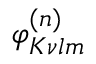<formula> <loc_0><loc_0><loc_500><loc_500>\varphi _ { K \nu l m } ^ { ( n ) }</formula> 